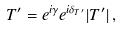Convert formula to latex. <formula><loc_0><loc_0><loc_500><loc_500>T ^ { \prime } = e ^ { i \gamma } e ^ { i \delta _ { T ^ { \prime } } } | T ^ { \prime } | \, ,</formula> 